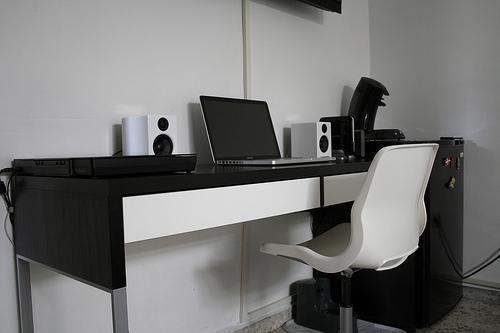How many speakers on the desk?
Give a very brief answer. 2. 